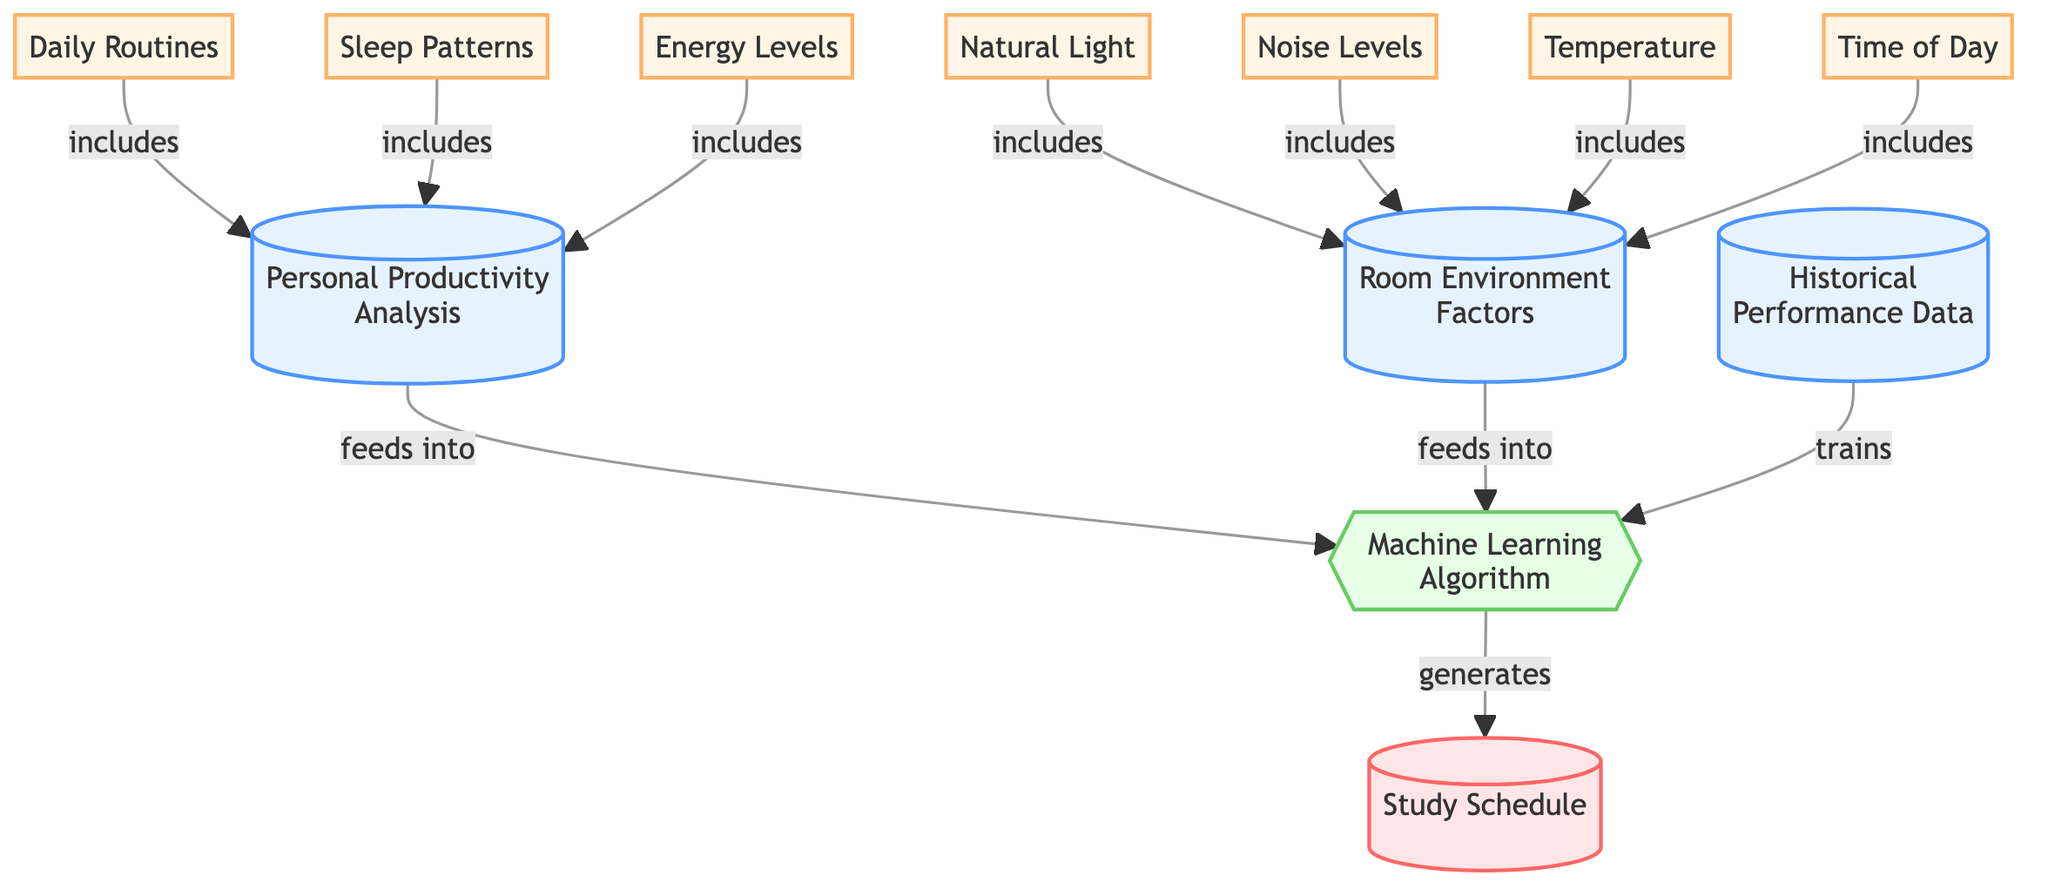What is the main output of this diagram? The main output of the diagram is the "Study Schedule", which is indicated as the final outcome generated by the machine learning algorithm.
Answer: Study Schedule How many data source nodes are present in the diagram? There are three data source nodes: "Personal Productivity Analysis," "Room Environment Factors," and "Historical Performance Data."
Answer: 3 What factors are included in "Room Environment Factors"? The factors included in "Room Environment Factors" are "Natural Light," "Noise Levels," "Temperature," and "Time of Day," as shown in the connections to node 6.
Answer: Natural Light, Noise Levels, Temperature, Time of Day Which node feeds into the machine learning algorithm to generate the study schedule? Both "Personal Productivity Analysis" and "Room Environment Factors" feed into the machine learning algorithm as indicated by the arrows leading to node 11.
Answer: Personal Productivity Analysis, Room Environment Factors Which nodes are included under "Daily Routines"? The nodes under "Daily Routines" include "Personal Productivity Analysis," which itself encompasses "Sleep Patterns" and "Energy Levels." This is evident from the structure of the diagram showing inclusivity.
Answer: Sleep Patterns, Energy Levels What is the role of "Historical Performance Data" in the diagram? "Historical Performance Data" is utilized to train the machine learning algorithm, helping it to generate a more effective study schedule based on past performance.
Answer: Trains machine learning algorithm How many variable nodes are connected to the “Room Environment Factors”? Four variable nodes are connected to the "Room Environment Factors": "Natural Light," "Noise Levels," "Temperature," and "Time of Day." These are directly related to node 6 in the diagram.
Answer: 4 What does the machine learning algorithm do in this diagram? The machine learning algorithm processes the inputs it receives from personal productivity and room environment factors to generate an effective study schedule.
Answer: Generates study schedule Which process node is present in the diagram? The only process node in the diagram is labeled as the "Machine Learning Algorithm," which indicates the process of generating the study schedule based on the provided inputs.
Answer: Machine Learning Algorithm 